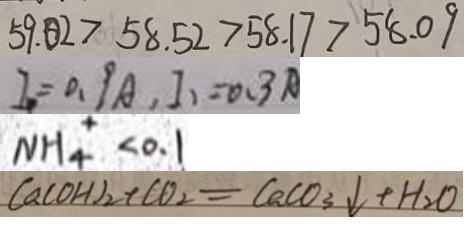<formula> <loc_0><loc_0><loc_500><loc_500>5 9 . 0 2 > 5 8 . 5 2 > 5 8 . 1 7 > 5 8 . 0 9 
 I _ { 1 } = 0 . 9 A , I _ { 1 } = 0 . 3 A 
 N H _ { 4 } ^ { + } < 0 . 1 
 C a ( O H ) _ { 2 } + C O _ { 2 } = C a C O _ { 3 } \downarrow + H _ { 2 } O</formula> 